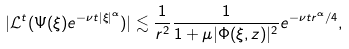Convert formula to latex. <formula><loc_0><loc_0><loc_500><loc_500>| \mathcal { L } ^ { t } ( \Psi ( \xi ) e ^ { - \nu t | \xi | ^ { \alpha } } ) | \lesssim \frac { 1 } { r ^ { 2 } } \frac { 1 } { 1 + \mu | \Phi ( \xi , z ) | ^ { 2 } } e ^ { - \nu t r ^ { \alpha } / 4 } ,</formula> 